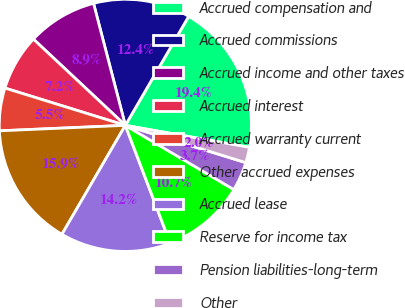Convert chart. <chart><loc_0><loc_0><loc_500><loc_500><pie_chart><fcel>Accrued compensation and<fcel>Accrued commissions<fcel>Accrued income and other taxes<fcel>Accrued interest<fcel>Accrued warranty current<fcel>Other accrued expenses<fcel>Accrued lease<fcel>Reserve for income tax<fcel>Pension liabilities-long-term<fcel>Other<nl><fcel>19.41%<fcel>12.44%<fcel>8.95%<fcel>7.21%<fcel>5.47%<fcel>15.92%<fcel>14.18%<fcel>10.7%<fcel>3.73%<fcel>1.99%<nl></chart> 